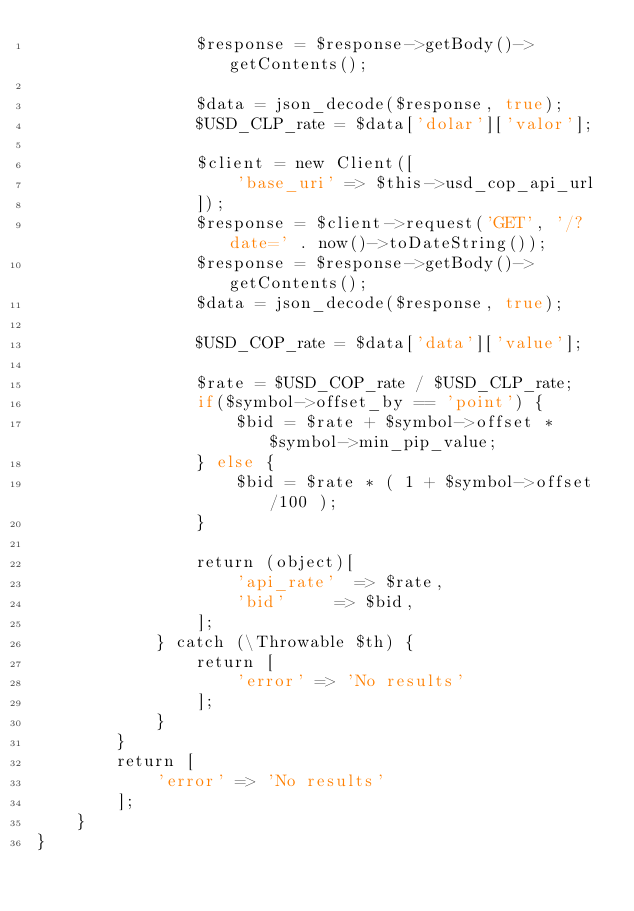Convert code to text. <code><loc_0><loc_0><loc_500><loc_500><_PHP_>                $response = $response->getBody()->getContents();
    
                $data = json_decode($response, true);
                $USD_CLP_rate = $data['dolar']['valor'];
    
                $client = new Client([
                    'base_uri' => $this->usd_cop_api_url
                ]);
                $response = $client->request('GET', '/?date=' . now()->toDateString());
                $response = $response->getBody()->getContents();
                $data = json_decode($response, true);
    
                $USD_COP_rate = $data['data']['value'];
    
                $rate = $USD_COP_rate / $USD_CLP_rate;
                if($symbol->offset_by == 'point') {
                    $bid = $rate + $symbol->offset * $symbol->min_pip_value;
                } else {
                    $bid = $rate * ( 1 + $symbol->offset/100 );
                }
    
                return (object)[
                    'api_rate'  => $rate,
                    'bid'     => $bid,
                ];
            } catch (\Throwable $th) {
                return [
                    'error' => 'No results'
                ];
            }
        }
        return [
            'error' => 'No results'
        ];
    }
}
</code> 